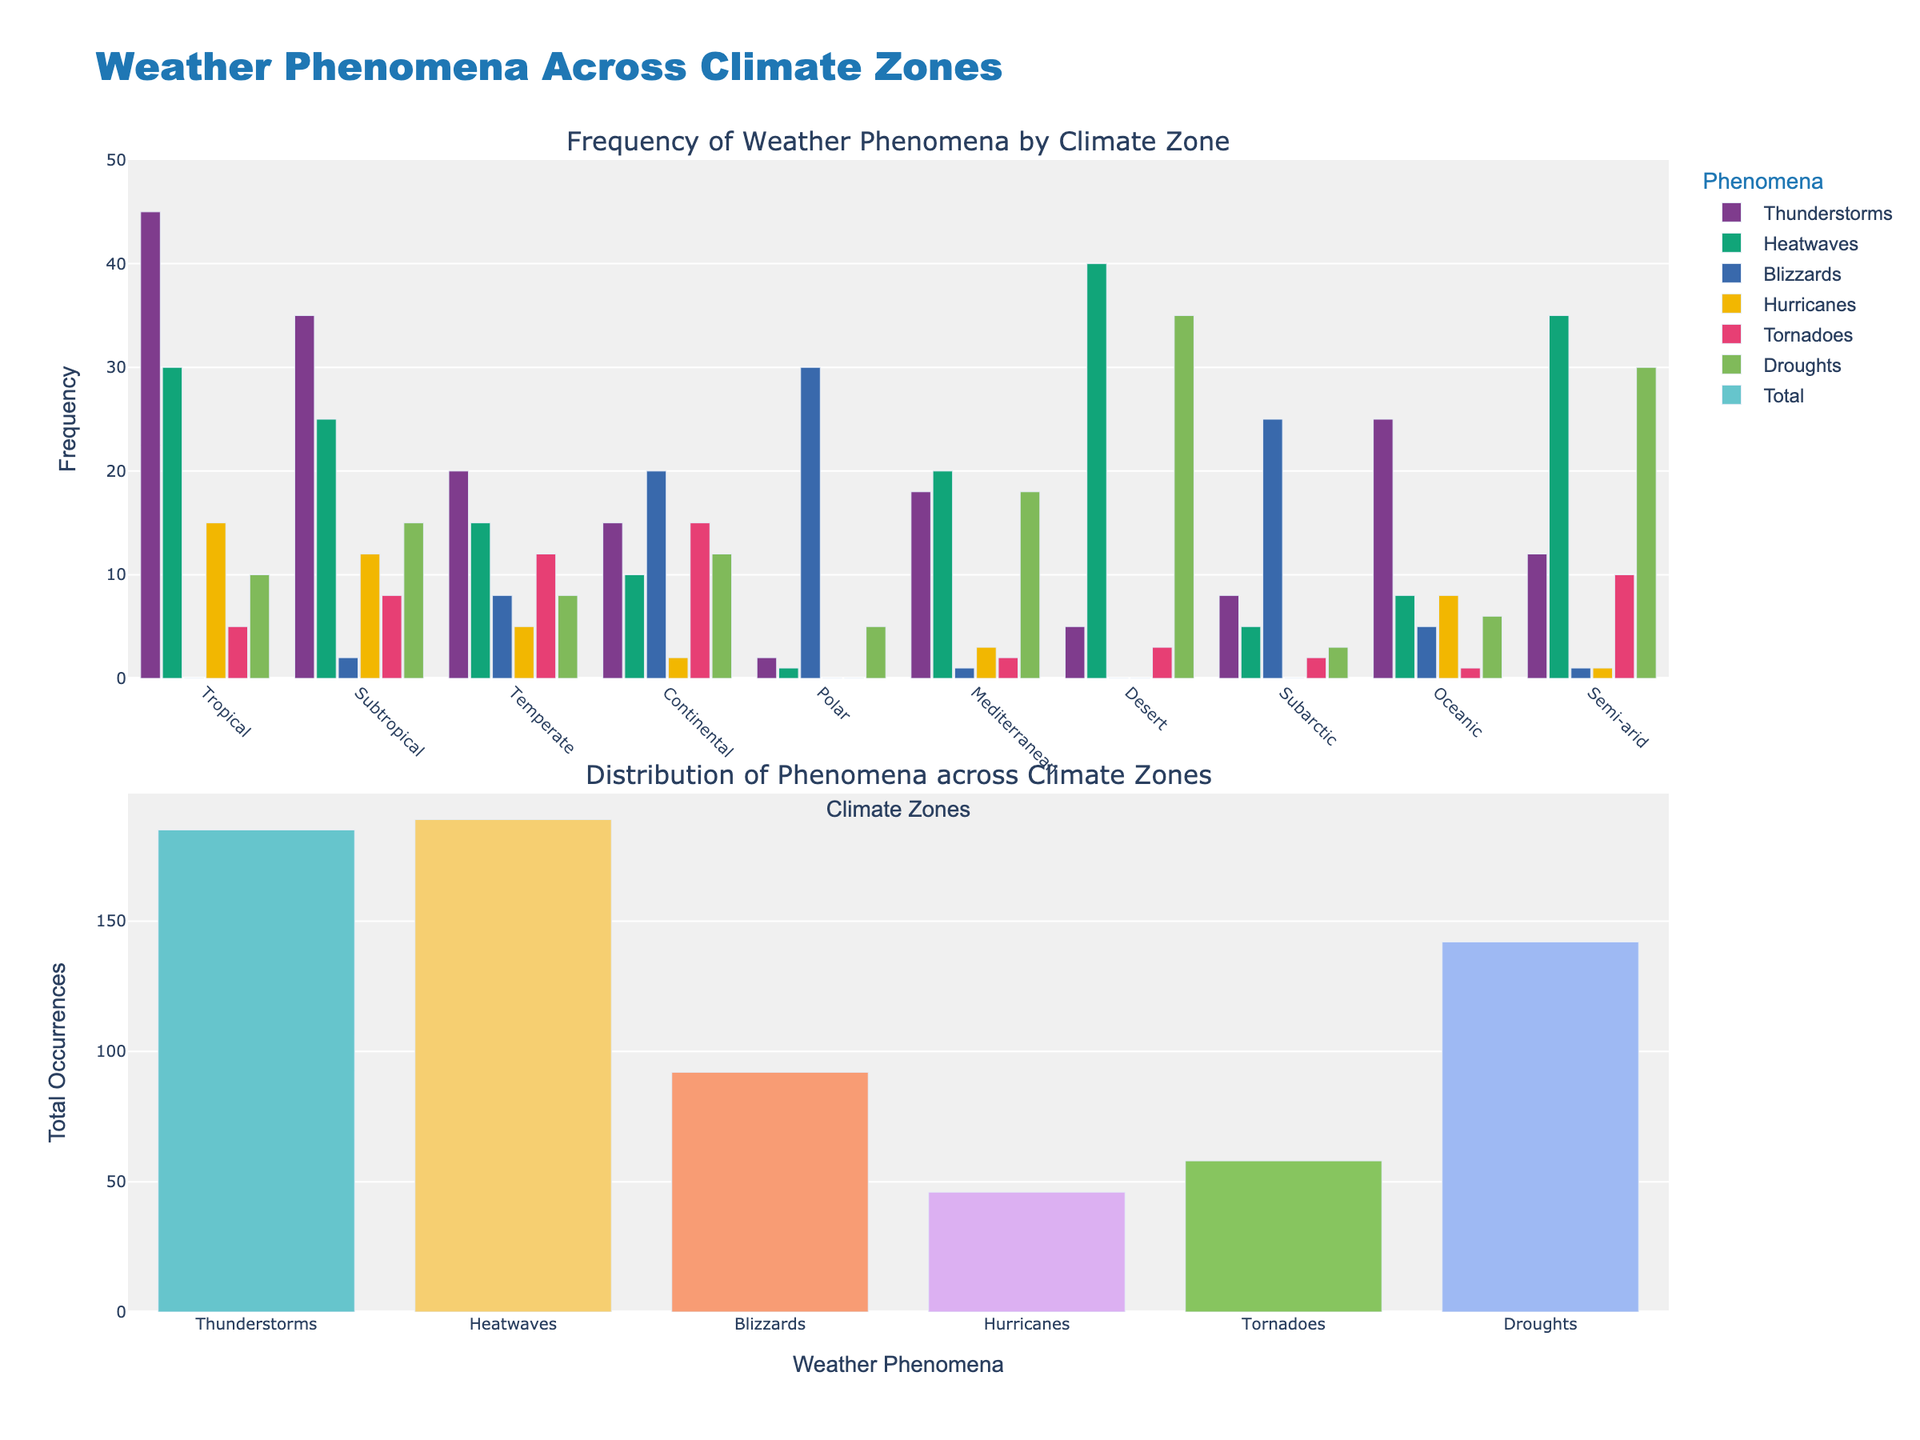What is the total frequency of thunderstorms across all climate zones? To find the total frequency of thunderstorms, sum the values for thunderstorms from all climate zones: 45 (Tropical) + 35 (Subtropical) + 20 (Temperate) + 15 (Continental) + 2 (Polar) + 18 (Mediterranean) + 5 (Desert) + 8 (Subarctic) + 25 (Oceanic) + 12 (Semi-arid) = 185.
Answer: 185 Which climate zone has the highest frequency of droughts? The climate zones and their drought values are as follows: 10 (Tropical), 15 (Subtropical), 8 (Temperate), 12 (Continental), 5 (Polar), 18 (Mediterranean), 35 (Desert), 3 (Subarctic), 6 (Oceanic), 30 (Semi-arid). Among these, Desert has the highest value of 35.
Answer: Desert What is the difference in frequency of blizzards between the Polar and Continental zones? The frequency of blizzards in the Polar zone is 30 and in the Continental zone is 20. The difference is 30 - 20 = 10.
Answer: 10 Which weather phenomenon occurs least frequently in the Subtropical zone? The frequencies of weather phenomena in the Subtropical zone are: Thunderstorms (35), Heatwaves (25), Blizzards (2), Hurricanes (12), Tornadoes (8), and Droughts (15). The least frequent phenomenon is Blizzards with a frequency of 2.
Answer: Blizzards How many more heatwaves occur in the Desert zone compared to the Temperate zone? The frequency of heatwaves in the Desert zone is 40 and in the Temperate zone is 15. The difference is 40 - 15 = 25.
Answer: 25 Which climate zone has the second highest frequency of tornadoes? The climate zones and their tornado values are: Tropical (5), Subtropical (8), Temperate (12), Continental (15), Polar (0), Mediterranean (2), Desert (3), Subarctic (2), Oceanic (1), Semi-arid (10). The highest is Continental with 15, and the second highest is Temperate with 12.
Answer: Temperate In which climate zone is the frequency of heatwaves greater than the sum of thunderstorm and blizzard frequencies? This holds if heatwaves > thunderstorms + blizzards. For each zone: Tropical (30 > 45+0=False), Subtropical (25 > 35+2=False), Temperate (15 > 20+8=False), Continental (10 > 15+20=False), Polar (1 > 2+30=False), Mediterranean (20 > 18+1=True), Desert (40 > 5+0=True), Subarctic (5 > 8+25=False), Oceanic (8 > 25+5=False), Semi-arid (35 > 12+1=True). Thus, Mediterranean, Desert, and Semi-arid meet the condition.
Answer: Mediterranean, Desert, Semi-arid What is the total number of hurricanes across all climate zones? The total number of hurricanes is the sum of all values for hurricanes: 15 (Tropical) + 12 (Subtropical) + 5 (Temperate) + 2 (Continental) + 0 (Polar) + 3 (Mediterranean) + 0 (Desert) + 0 (Subarctic) + 8 (Oceanic) + 1 (Semi-arid) = 46.
Answer: 46 